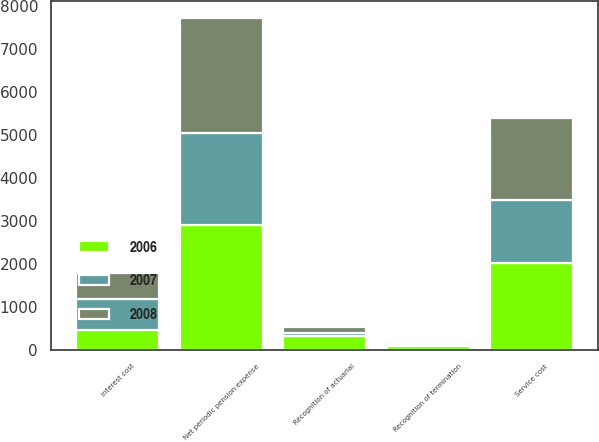<chart> <loc_0><loc_0><loc_500><loc_500><stacked_bar_chart><ecel><fcel>Service cost<fcel>Interest cost<fcel>Recognition of actuarial<fcel>Recognition of termination<fcel>Net periodic pension expense<nl><fcel>2007<fcel>1470<fcel>717<fcel>74<fcel>40<fcel>2153<nl><fcel>2008<fcel>1922<fcel>599<fcel>129<fcel>24<fcel>2674<nl><fcel>2006<fcel>2013<fcel>471<fcel>321<fcel>98<fcel>2903<nl></chart> 